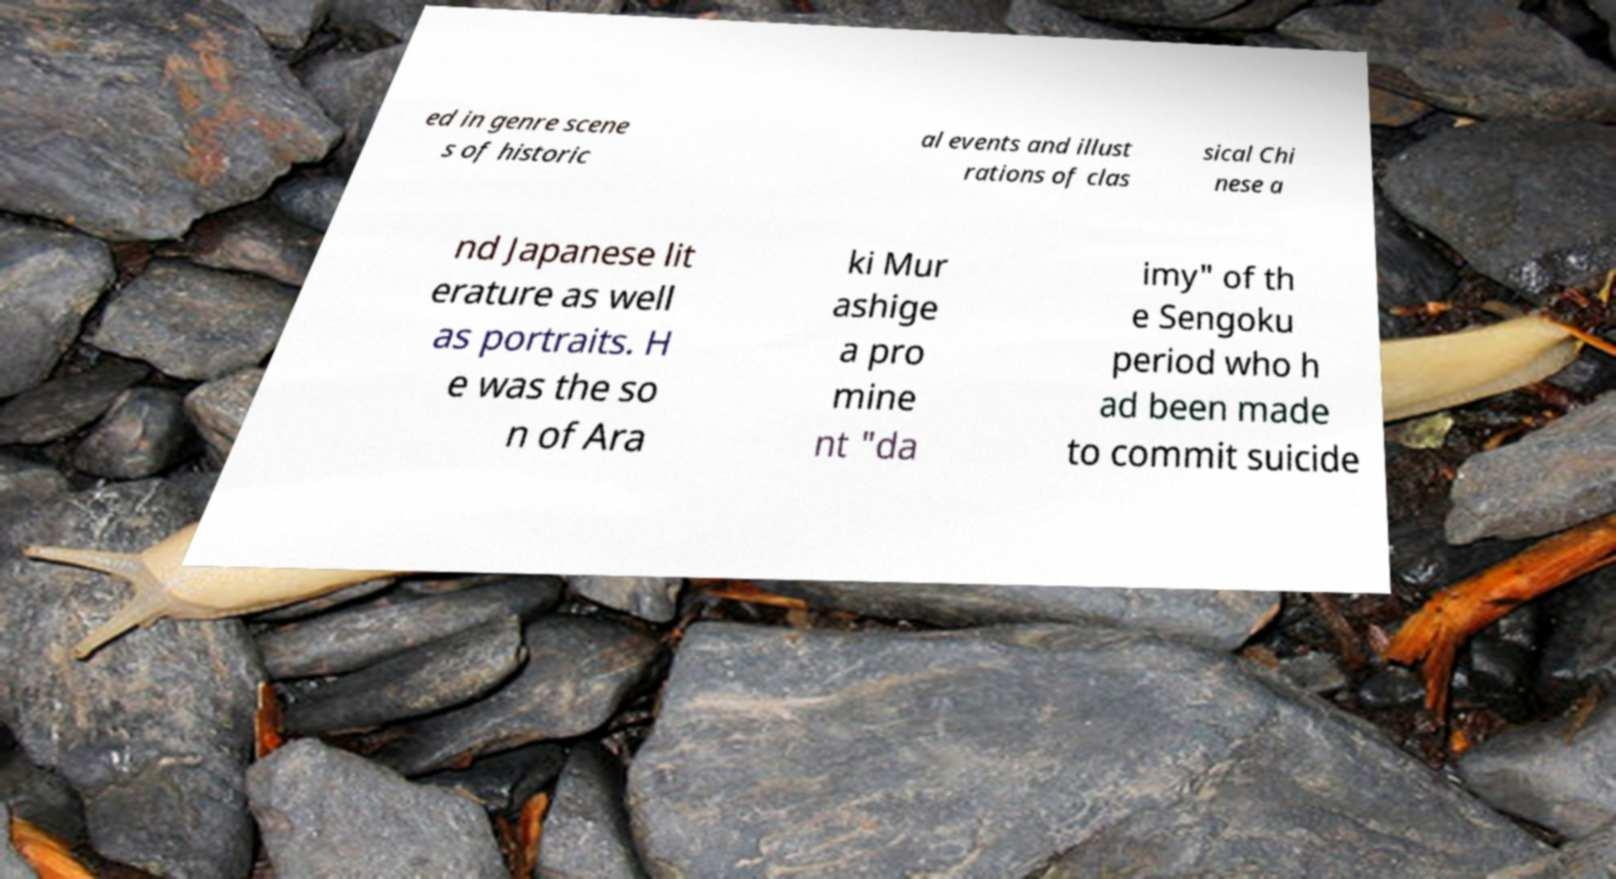I need the written content from this picture converted into text. Can you do that? ed in genre scene s of historic al events and illust rations of clas sical Chi nese a nd Japanese lit erature as well as portraits. H e was the so n of Ara ki Mur ashige a pro mine nt "da imy" of th e Sengoku period who h ad been made to commit suicide 